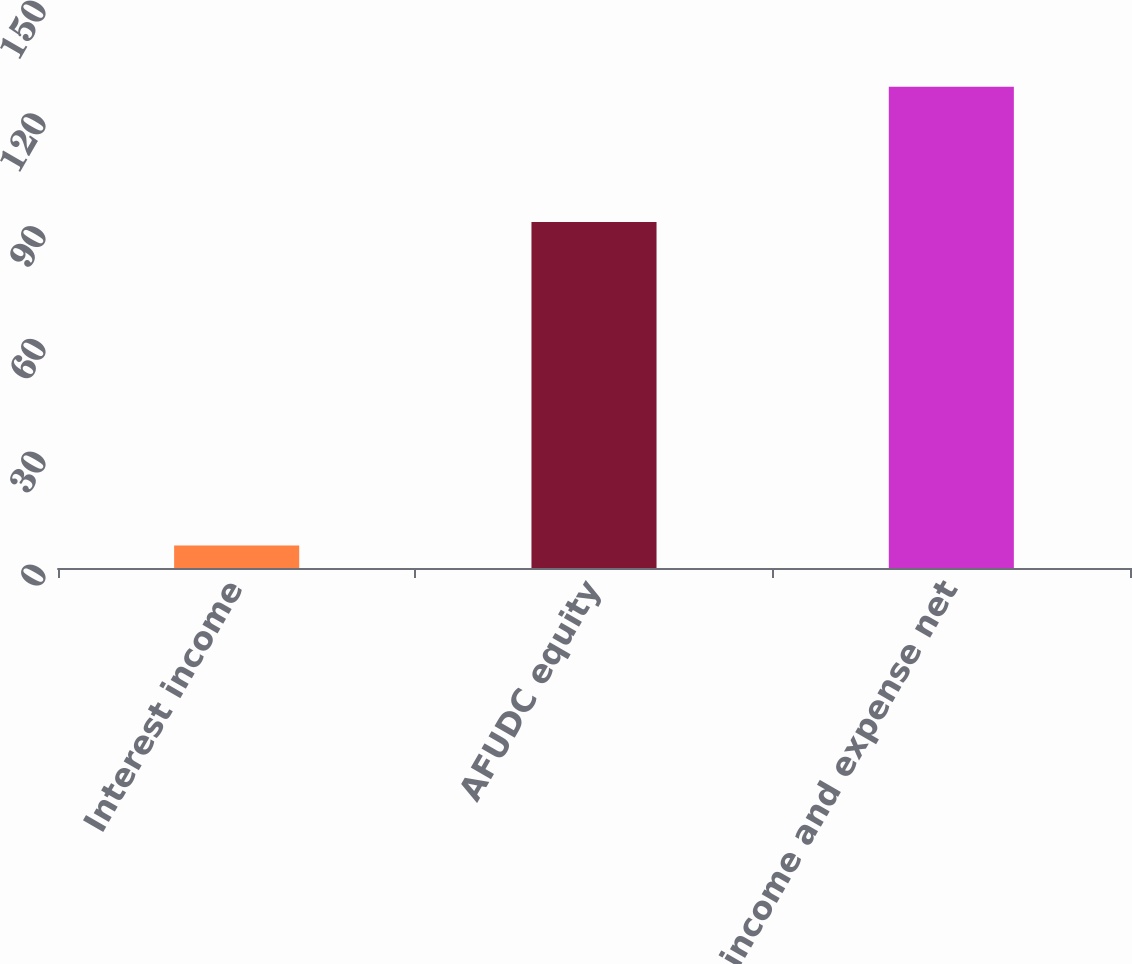Convert chart. <chart><loc_0><loc_0><loc_500><loc_500><bar_chart><fcel>Interest income<fcel>AFUDC equity<fcel>Other income and expense net<nl><fcel>6<fcel>92<fcel>128<nl></chart> 